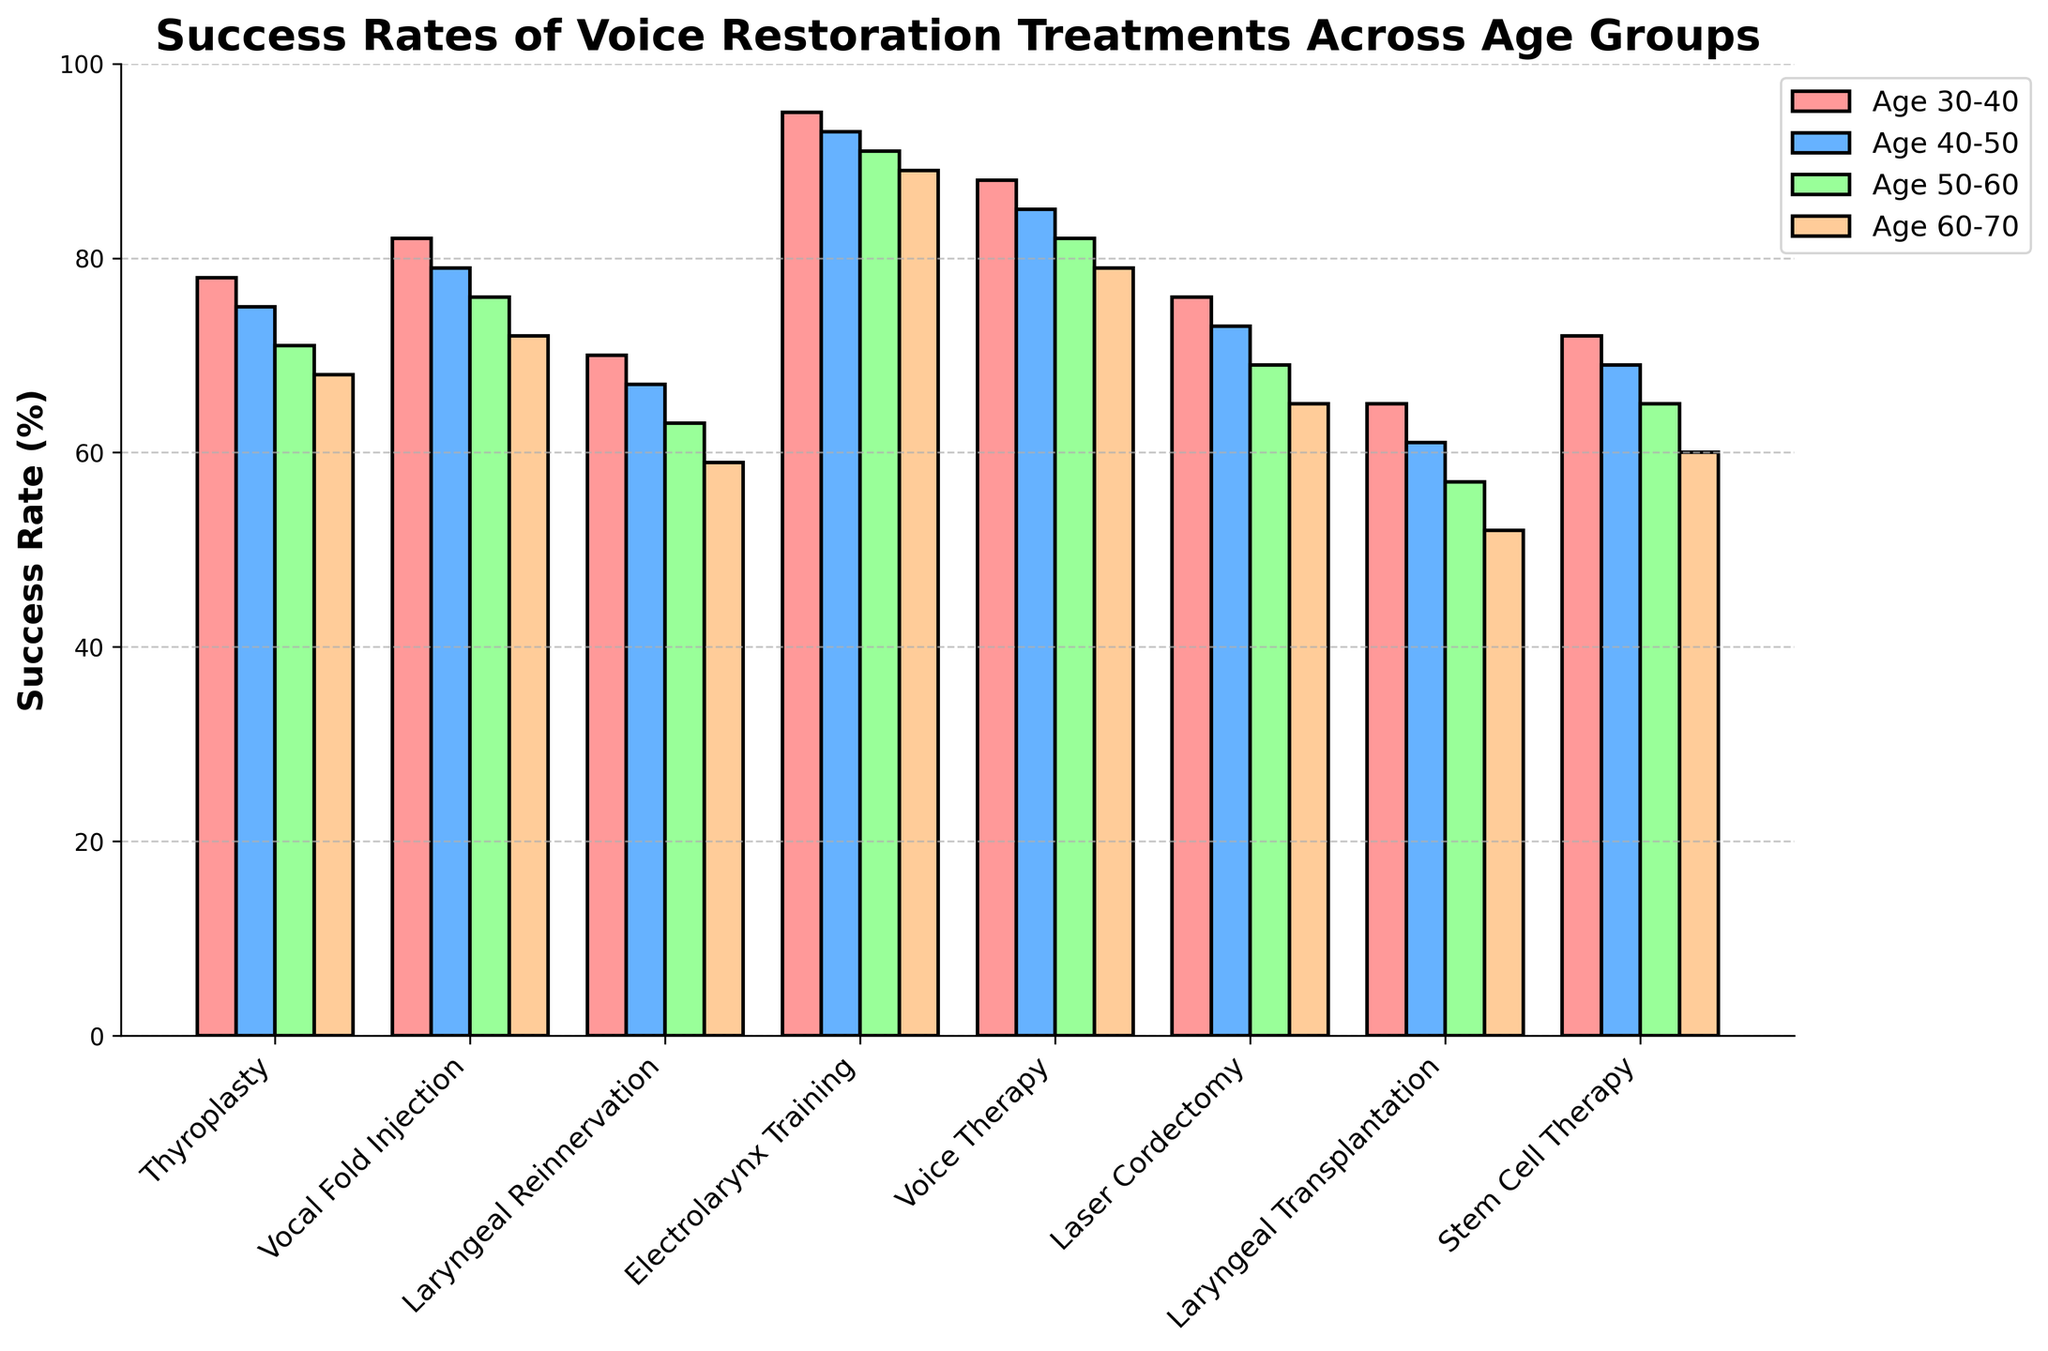What's the most successful treatment for voice restoration across all age groups? By looking at the heights of the bars, Electrolarynx Training has the highest success rates in all age groups.
Answer: Electrolarynx Training Which treatment shows the greatest drop in success rate between the age groups 30-40 and 60-70? The bar for Laryngeal Transplantation decreases from 65 (Age 30-40) to 52 (Age 60-70), which is a drop of 13 percentage points, the greatest among all treatments.
Answer: Laryngeal Transplantation What is the average success rate of Vocal Fold Injection across all age groups? The success rates for Vocal Fold Injection are 82, 79, 76, and 72. Adding these together gives 309, and dividing by 4 (number of age groups) results in 77.25.
Answer: 77.25 How do the success rates of Thyroplasty and Laser Cordectomy compare within the age group 50-60? The bar for Thyroplasty in the 50-60 age group is at 71, while the bar for Laser Cordectomy is at 69.
Answer: Thyroplasty has a higher success rate than Laser Cordectomy in the 50-60 age group Which age group has the highest average success rate across all treatments? Summing the success rates across all treatments for each age group and finding the average, we get: Age 30-40= 626/8 = 78.25, Age 40-50=602/8=75.25, Age 50-60=593/8=74.125, Age 60-70= 544/8=68. So, Age 30-40 has the highest average.
Answer: Age 30-40 What is the difference in success rate for Voice Therapy between the age groups 40-50 and 60-70? The success rate for Voice Therapy in age group 40-50 is 85, and for 60-70, it is 79. The difference is 85 - 79, which equals 6.
Answer: 6 Which treatments have a success rate of over 90% in the age group 50-60? By scanning the bars for the age group 50-60, only Electrolarynx Training with a success rate of 91 exceeds 90%.
Answer: Electrolarynx Training How does the success rate of Stem Cell Therapy for the age group 50-60 compare to Laryngeal Reinnervation for the age group 30-40? Stem Cell Therapy for age 50-60 has a success rate of 65, while Laryngeal Reinnervation for age 30-40 has a success rate of 70.
Answer: Stem Cell Therapy has a lower success rate What's the total success rate for Laser Cordectomy for all age groups? The success rates are 76, 73, 69, and 65. Summing these up gives 283.
Answer: 283 